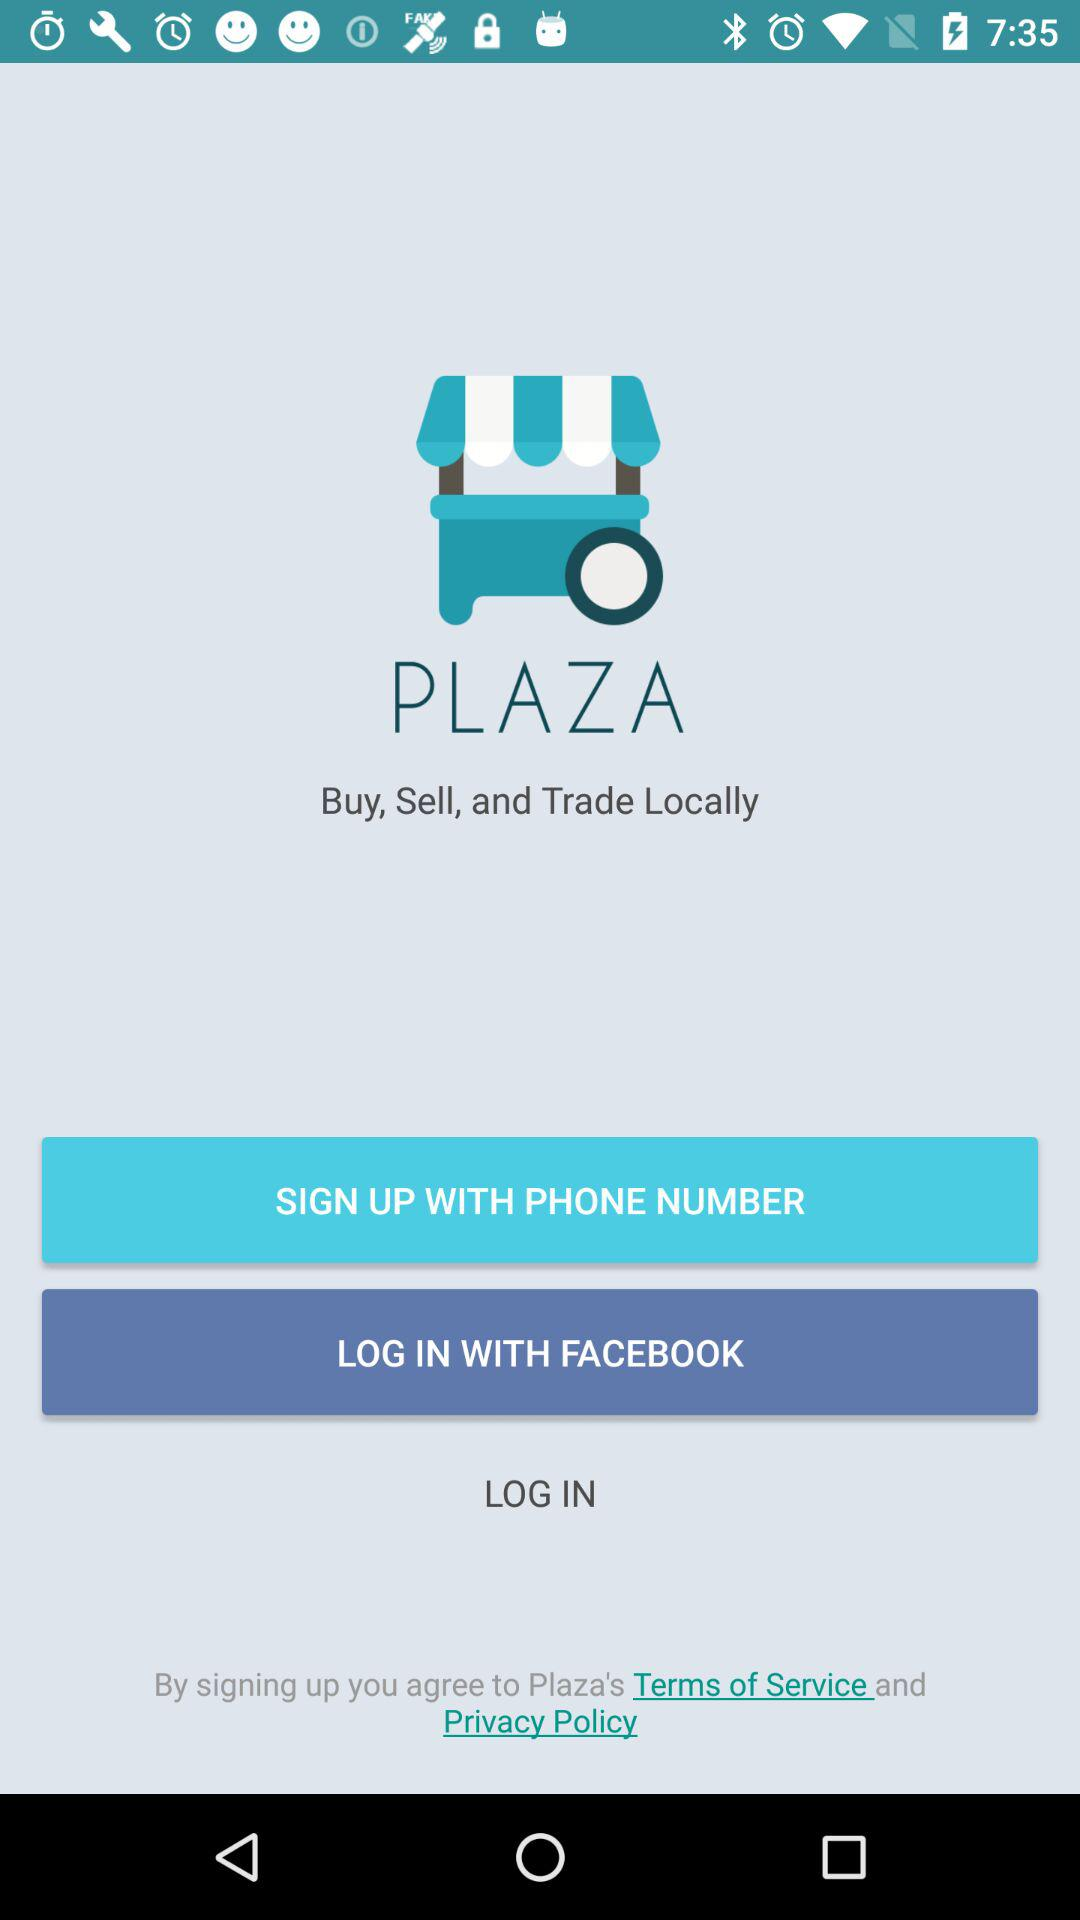Which application can be used to log in? The application that can be used to log in is "FACEBOOK". 